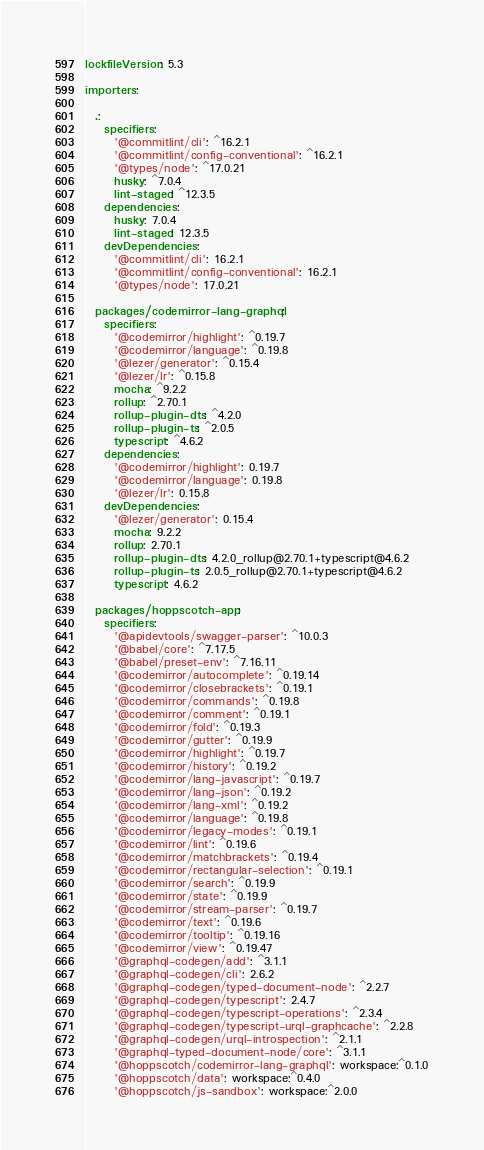Convert code to text. <code><loc_0><loc_0><loc_500><loc_500><_YAML_>lockfileVersion: 5.3

importers:

  .:
    specifiers:
      '@commitlint/cli': ^16.2.1
      '@commitlint/config-conventional': ^16.2.1
      '@types/node': ^17.0.21
      husky: ^7.0.4
      lint-staged: ^12.3.5
    dependencies:
      husky: 7.0.4
      lint-staged: 12.3.5
    devDependencies:
      '@commitlint/cli': 16.2.1
      '@commitlint/config-conventional': 16.2.1
      '@types/node': 17.0.21

  packages/codemirror-lang-graphql:
    specifiers:
      '@codemirror/highlight': ^0.19.7
      '@codemirror/language': ^0.19.8
      '@lezer/generator': ^0.15.4
      '@lezer/lr': ^0.15.8
      mocha: ^9.2.2
      rollup: ^2.70.1
      rollup-plugin-dts: ^4.2.0
      rollup-plugin-ts: ^2.0.5
      typescript: ^4.6.2
    dependencies:
      '@codemirror/highlight': 0.19.7
      '@codemirror/language': 0.19.8
      '@lezer/lr': 0.15.8
    devDependencies:
      '@lezer/generator': 0.15.4
      mocha: 9.2.2
      rollup: 2.70.1
      rollup-plugin-dts: 4.2.0_rollup@2.70.1+typescript@4.6.2
      rollup-plugin-ts: 2.0.5_rollup@2.70.1+typescript@4.6.2
      typescript: 4.6.2

  packages/hoppscotch-app:
    specifiers:
      '@apidevtools/swagger-parser': ^10.0.3
      '@babel/core': ^7.17.5
      '@babel/preset-env': ^7.16.11
      '@codemirror/autocomplete': ^0.19.14
      '@codemirror/closebrackets': ^0.19.1
      '@codemirror/commands': ^0.19.8
      '@codemirror/comment': ^0.19.1
      '@codemirror/fold': ^0.19.3
      '@codemirror/gutter': ^0.19.9
      '@codemirror/highlight': ^0.19.7
      '@codemirror/history': ^0.19.2
      '@codemirror/lang-javascript': ^0.19.7
      '@codemirror/lang-json': ^0.19.2
      '@codemirror/lang-xml': ^0.19.2
      '@codemirror/language': ^0.19.8
      '@codemirror/legacy-modes': ^0.19.1
      '@codemirror/lint': ^0.19.6
      '@codemirror/matchbrackets': ^0.19.4
      '@codemirror/rectangular-selection': ^0.19.1
      '@codemirror/search': ^0.19.9
      '@codemirror/state': ^0.19.9
      '@codemirror/stream-parser': ^0.19.7
      '@codemirror/text': ^0.19.6
      '@codemirror/tooltip': ^0.19.16
      '@codemirror/view': ^0.19.47
      '@graphql-codegen/add': ^3.1.1
      '@graphql-codegen/cli': 2.6.2
      '@graphql-codegen/typed-document-node': ^2.2.7
      '@graphql-codegen/typescript': 2.4.7
      '@graphql-codegen/typescript-operations': ^2.3.4
      '@graphql-codegen/typescript-urql-graphcache': ^2.2.8
      '@graphql-codegen/urql-introspection': ^2.1.1
      '@graphql-typed-document-node/core': ^3.1.1
      '@hoppscotch/codemirror-lang-graphql': workspace:^0.1.0
      '@hoppscotch/data': workspace:^0.4.0
      '@hoppscotch/js-sandbox': workspace:^2.0.0</code> 